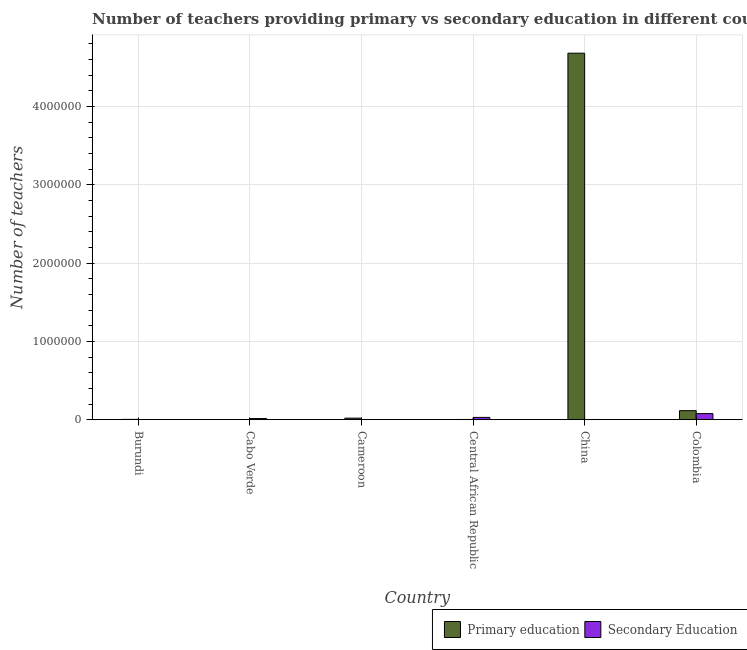Are the number of bars on each tick of the X-axis equal?
Provide a succinct answer. Yes. How many bars are there on the 6th tick from the left?
Provide a short and direct response. 2. How many bars are there on the 4th tick from the right?
Make the answer very short. 2. What is the label of the 2nd group of bars from the left?
Keep it short and to the point. Cabo Verde. What is the number of primary teachers in Central African Republic?
Your answer should be compact. 3083. Across all countries, what is the maximum number of secondary teachers?
Ensure brevity in your answer.  7.80e+04. Across all countries, what is the minimum number of primary teachers?
Offer a terse response. 1068. In which country was the number of secondary teachers minimum?
Keep it short and to the point. Burundi. What is the total number of primary teachers in the graph?
Your response must be concise. 4.82e+06. What is the difference between the number of secondary teachers in China and that in Colombia?
Ensure brevity in your answer.  -7.54e+04. What is the difference between the number of secondary teachers in China and the number of primary teachers in Burundi?
Make the answer very short. -1432. What is the average number of secondary teachers per country?
Provide a short and direct response. 2.10e+04. What is the difference between the number of primary teachers and number of secondary teachers in Central African Republic?
Give a very brief answer. -2.62e+04. What is the ratio of the number of primary teachers in Cabo Verde to that in China?
Your response must be concise. 0. Is the difference between the number of secondary teachers in Central African Republic and Colombia greater than the difference between the number of primary teachers in Central African Republic and Colombia?
Offer a very short reply. Yes. What is the difference between the highest and the second highest number of secondary teachers?
Offer a very short reply. 4.87e+04. What is the difference between the highest and the lowest number of primary teachers?
Ensure brevity in your answer.  4.68e+06. In how many countries, is the number of secondary teachers greater than the average number of secondary teachers taken over all countries?
Your response must be concise. 2. Is the sum of the number of primary teachers in Cabo Verde and Central African Republic greater than the maximum number of secondary teachers across all countries?
Provide a succinct answer. No. What does the 2nd bar from the left in Burundi represents?
Provide a succinct answer. Secondary Education. What does the 2nd bar from the right in China represents?
Offer a terse response. Primary education. How many countries are there in the graph?
Offer a terse response. 6. Does the graph contain any zero values?
Make the answer very short. No. Does the graph contain grids?
Offer a very short reply. Yes. How many legend labels are there?
Offer a very short reply. 2. How are the legend labels stacked?
Your answer should be very brief. Horizontal. What is the title of the graph?
Provide a succinct answer. Number of teachers providing primary vs secondary education in different countries. Does "Foreign Liabilities" appear as one of the legend labels in the graph?
Your answer should be compact. No. What is the label or title of the X-axis?
Give a very brief answer. Country. What is the label or title of the Y-axis?
Your answer should be very brief. Number of teachers. What is the Number of teachers in Primary education in Burundi?
Your answer should be compact. 4022. What is the Number of teachers in Secondary Education in Burundi?
Offer a terse response. 128. What is the Number of teachers of Primary education in Cabo Verde?
Provide a succinct answer. 1068. What is the Number of teachers of Secondary Education in Cabo Verde?
Offer a very short reply. 1.45e+04. What is the Number of teachers of Primary education in Cameroon?
Offer a terse response. 1.97e+04. What is the Number of teachers in Secondary Education in Cameroon?
Provide a short and direct response. 1681. What is the Number of teachers in Primary education in Central African Republic?
Provide a succinct answer. 3083. What is the Number of teachers of Secondary Education in Central African Republic?
Keep it short and to the point. 2.93e+04. What is the Number of teachers in Primary education in China?
Offer a terse response. 4.68e+06. What is the Number of teachers of Secondary Education in China?
Keep it short and to the point. 2590. What is the Number of teachers of Primary education in Colombia?
Your response must be concise. 1.15e+05. What is the Number of teachers in Secondary Education in Colombia?
Offer a very short reply. 7.80e+04. Across all countries, what is the maximum Number of teachers of Primary education?
Your answer should be very brief. 4.68e+06. Across all countries, what is the maximum Number of teachers in Secondary Education?
Give a very brief answer. 7.80e+04. Across all countries, what is the minimum Number of teachers in Primary education?
Your response must be concise. 1068. Across all countries, what is the minimum Number of teachers of Secondary Education?
Offer a terse response. 128. What is the total Number of teachers of Primary education in the graph?
Ensure brevity in your answer.  4.82e+06. What is the total Number of teachers in Secondary Education in the graph?
Make the answer very short. 1.26e+05. What is the difference between the Number of teachers of Primary education in Burundi and that in Cabo Verde?
Ensure brevity in your answer.  2954. What is the difference between the Number of teachers in Secondary Education in Burundi and that in Cabo Verde?
Your response must be concise. -1.44e+04. What is the difference between the Number of teachers in Primary education in Burundi and that in Cameroon?
Ensure brevity in your answer.  -1.57e+04. What is the difference between the Number of teachers of Secondary Education in Burundi and that in Cameroon?
Give a very brief answer. -1553. What is the difference between the Number of teachers in Primary education in Burundi and that in Central African Republic?
Offer a very short reply. 939. What is the difference between the Number of teachers of Secondary Education in Burundi and that in Central African Republic?
Your answer should be compact. -2.91e+04. What is the difference between the Number of teachers of Primary education in Burundi and that in China?
Provide a short and direct response. -4.67e+06. What is the difference between the Number of teachers in Secondary Education in Burundi and that in China?
Offer a terse response. -2462. What is the difference between the Number of teachers of Primary education in Burundi and that in Colombia?
Your answer should be very brief. -1.11e+05. What is the difference between the Number of teachers in Secondary Education in Burundi and that in Colombia?
Keep it short and to the point. -7.78e+04. What is the difference between the Number of teachers in Primary education in Cabo Verde and that in Cameroon?
Offer a terse response. -1.87e+04. What is the difference between the Number of teachers of Secondary Education in Cabo Verde and that in Cameroon?
Keep it short and to the point. 1.28e+04. What is the difference between the Number of teachers in Primary education in Cabo Verde and that in Central African Republic?
Your answer should be compact. -2015. What is the difference between the Number of teachers in Secondary Education in Cabo Verde and that in Central African Republic?
Give a very brief answer. -1.48e+04. What is the difference between the Number of teachers of Primary education in Cabo Verde and that in China?
Keep it short and to the point. -4.68e+06. What is the difference between the Number of teachers of Secondary Education in Cabo Verde and that in China?
Give a very brief answer. 1.19e+04. What is the difference between the Number of teachers of Primary education in Cabo Verde and that in Colombia?
Your answer should be compact. -1.14e+05. What is the difference between the Number of teachers in Secondary Education in Cabo Verde and that in Colombia?
Offer a terse response. -6.35e+04. What is the difference between the Number of teachers in Primary education in Cameroon and that in Central African Republic?
Make the answer very short. 1.66e+04. What is the difference between the Number of teachers of Secondary Education in Cameroon and that in Central African Republic?
Offer a terse response. -2.76e+04. What is the difference between the Number of teachers of Primary education in Cameroon and that in China?
Keep it short and to the point. -4.66e+06. What is the difference between the Number of teachers of Secondary Education in Cameroon and that in China?
Ensure brevity in your answer.  -909. What is the difference between the Number of teachers in Primary education in Cameroon and that in Colombia?
Keep it short and to the point. -9.56e+04. What is the difference between the Number of teachers in Secondary Education in Cameroon and that in Colombia?
Provide a short and direct response. -7.63e+04. What is the difference between the Number of teachers in Primary education in Central African Republic and that in China?
Offer a very short reply. -4.68e+06. What is the difference between the Number of teachers in Secondary Education in Central African Republic and that in China?
Keep it short and to the point. 2.67e+04. What is the difference between the Number of teachers in Primary education in Central African Republic and that in Colombia?
Provide a short and direct response. -1.12e+05. What is the difference between the Number of teachers of Secondary Education in Central African Republic and that in Colombia?
Make the answer very short. -4.87e+04. What is the difference between the Number of teachers of Primary education in China and that in Colombia?
Make the answer very short. 4.56e+06. What is the difference between the Number of teachers in Secondary Education in China and that in Colombia?
Provide a succinct answer. -7.54e+04. What is the difference between the Number of teachers of Primary education in Burundi and the Number of teachers of Secondary Education in Cabo Verde?
Give a very brief answer. -1.05e+04. What is the difference between the Number of teachers in Primary education in Burundi and the Number of teachers in Secondary Education in Cameroon?
Give a very brief answer. 2341. What is the difference between the Number of teachers in Primary education in Burundi and the Number of teachers in Secondary Education in Central African Republic?
Provide a short and direct response. -2.52e+04. What is the difference between the Number of teachers of Primary education in Burundi and the Number of teachers of Secondary Education in China?
Make the answer very short. 1432. What is the difference between the Number of teachers of Primary education in Burundi and the Number of teachers of Secondary Education in Colombia?
Your response must be concise. -7.39e+04. What is the difference between the Number of teachers of Primary education in Cabo Verde and the Number of teachers of Secondary Education in Cameroon?
Provide a short and direct response. -613. What is the difference between the Number of teachers of Primary education in Cabo Verde and the Number of teachers of Secondary Education in Central African Republic?
Your answer should be very brief. -2.82e+04. What is the difference between the Number of teachers in Primary education in Cabo Verde and the Number of teachers in Secondary Education in China?
Offer a very short reply. -1522. What is the difference between the Number of teachers of Primary education in Cabo Verde and the Number of teachers of Secondary Education in Colombia?
Provide a short and direct response. -7.69e+04. What is the difference between the Number of teachers of Primary education in Cameroon and the Number of teachers of Secondary Education in Central African Republic?
Provide a succinct answer. -9541. What is the difference between the Number of teachers of Primary education in Cameroon and the Number of teachers of Secondary Education in China?
Offer a terse response. 1.71e+04. What is the difference between the Number of teachers in Primary education in Cameroon and the Number of teachers in Secondary Education in Colombia?
Provide a short and direct response. -5.82e+04. What is the difference between the Number of teachers of Primary education in Central African Republic and the Number of teachers of Secondary Education in China?
Keep it short and to the point. 493. What is the difference between the Number of teachers in Primary education in Central African Republic and the Number of teachers in Secondary Education in Colombia?
Provide a short and direct response. -7.49e+04. What is the difference between the Number of teachers in Primary education in China and the Number of teachers in Secondary Education in Colombia?
Offer a very short reply. 4.60e+06. What is the average Number of teachers in Primary education per country?
Offer a very short reply. 8.04e+05. What is the average Number of teachers of Secondary Education per country?
Offer a very short reply. 2.10e+04. What is the difference between the Number of teachers of Primary education and Number of teachers of Secondary Education in Burundi?
Your answer should be very brief. 3894. What is the difference between the Number of teachers in Primary education and Number of teachers in Secondary Education in Cabo Verde?
Keep it short and to the point. -1.34e+04. What is the difference between the Number of teachers in Primary education and Number of teachers in Secondary Education in Cameroon?
Make the answer very short. 1.80e+04. What is the difference between the Number of teachers of Primary education and Number of teachers of Secondary Education in Central African Republic?
Ensure brevity in your answer.  -2.62e+04. What is the difference between the Number of teachers of Primary education and Number of teachers of Secondary Education in China?
Make the answer very short. 4.68e+06. What is the difference between the Number of teachers in Primary education and Number of teachers in Secondary Education in Colombia?
Provide a short and direct response. 3.73e+04. What is the ratio of the Number of teachers of Primary education in Burundi to that in Cabo Verde?
Your answer should be compact. 3.77. What is the ratio of the Number of teachers of Secondary Education in Burundi to that in Cabo Verde?
Your answer should be compact. 0.01. What is the ratio of the Number of teachers in Primary education in Burundi to that in Cameroon?
Ensure brevity in your answer.  0.2. What is the ratio of the Number of teachers in Secondary Education in Burundi to that in Cameroon?
Your answer should be compact. 0.08. What is the ratio of the Number of teachers of Primary education in Burundi to that in Central African Republic?
Offer a terse response. 1.3. What is the ratio of the Number of teachers in Secondary Education in Burundi to that in Central African Republic?
Your answer should be very brief. 0. What is the ratio of the Number of teachers of Primary education in Burundi to that in China?
Your answer should be compact. 0. What is the ratio of the Number of teachers in Secondary Education in Burundi to that in China?
Offer a terse response. 0.05. What is the ratio of the Number of teachers in Primary education in Burundi to that in Colombia?
Your answer should be very brief. 0.03. What is the ratio of the Number of teachers in Secondary Education in Burundi to that in Colombia?
Make the answer very short. 0. What is the ratio of the Number of teachers of Primary education in Cabo Verde to that in Cameroon?
Give a very brief answer. 0.05. What is the ratio of the Number of teachers of Secondary Education in Cabo Verde to that in Cameroon?
Your response must be concise. 8.62. What is the ratio of the Number of teachers in Primary education in Cabo Verde to that in Central African Republic?
Your answer should be very brief. 0.35. What is the ratio of the Number of teachers of Secondary Education in Cabo Verde to that in Central African Republic?
Offer a very short reply. 0.49. What is the ratio of the Number of teachers in Primary education in Cabo Verde to that in China?
Keep it short and to the point. 0. What is the ratio of the Number of teachers of Secondary Education in Cabo Verde to that in China?
Your answer should be very brief. 5.59. What is the ratio of the Number of teachers in Primary education in Cabo Verde to that in Colombia?
Ensure brevity in your answer.  0.01. What is the ratio of the Number of teachers in Secondary Education in Cabo Verde to that in Colombia?
Provide a short and direct response. 0.19. What is the ratio of the Number of teachers in Primary education in Cameroon to that in Central African Republic?
Make the answer very short. 6.4. What is the ratio of the Number of teachers of Secondary Education in Cameroon to that in Central African Republic?
Make the answer very short. 0.06. What is the ratio of the Number of teachers of Primary education in Cameroon to that in China?
Keep it short and to the point. 0. What is the ratio of the Number of teachers in Secondary Education in Cameroon to that in China?
Your answer should be compact. 0.65. What is the ratio of the Number of teachers of Primary education in Cameroon to that in Colombia?
Your answer should be compact. 0.17. What is the ratio of the Number of teachers in Secondary Education in Cameroon to that in Colombia?
Ensure brevity in your answer.  0.02. What is the ratio of the Number of teachers in Primary education in Central African Republic to that in China?
Offer a very short reply. 0. What is the ratio of the Number of teachers in Secondary Education in Central African Republic to that in China?
Make the answer very short. 11.3. What is the ratio of the Number of teachers in Primary education in Central African Republic to that in Colombia?
Keep it short and to the point. 0.03. What is the ratio of the Number of teachers in Secondary Education in Central African Republic to that in Colombia?
Ensure brevity in your answer.  0.38. What is the ratio of the Number of teachers in Primary education in China to that in Colombia?
Make the answer very short. 40.58. What is the ratio of the Number of teachers in Secondary Education in China to that in Colombia?
Provide a short and direct response. 0.03. What is the difference between the highest and the second highest Number of teachers in Primary education?
Offer a terse response. 4.56e+06. What is the difference between the highest and the second highest Number of teachers in Secondary Education?
Make the answer very short. 4.87e+04. What is the difference between the highest and the lowest Number of teachers in Primary education?
Keep it short and to the point. 4.68e+06. What is the difference between the highest and the lowest Number of teachers of Secondary Education?
Your response must be concise. 7.78e+04. 